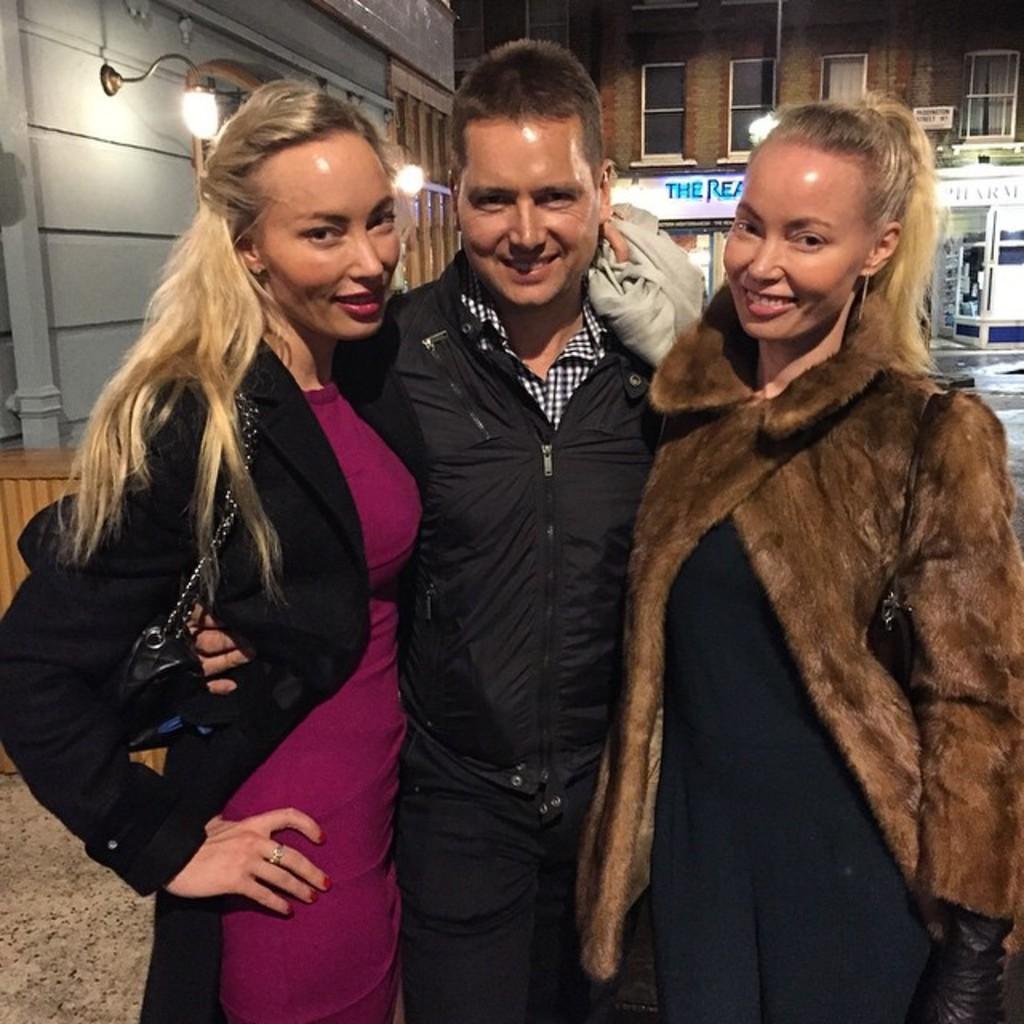Please provide a concise description of this image. In this picture we can see a man and two women, they are smiling, behind them we can find few buildings, lights and hoardings. 